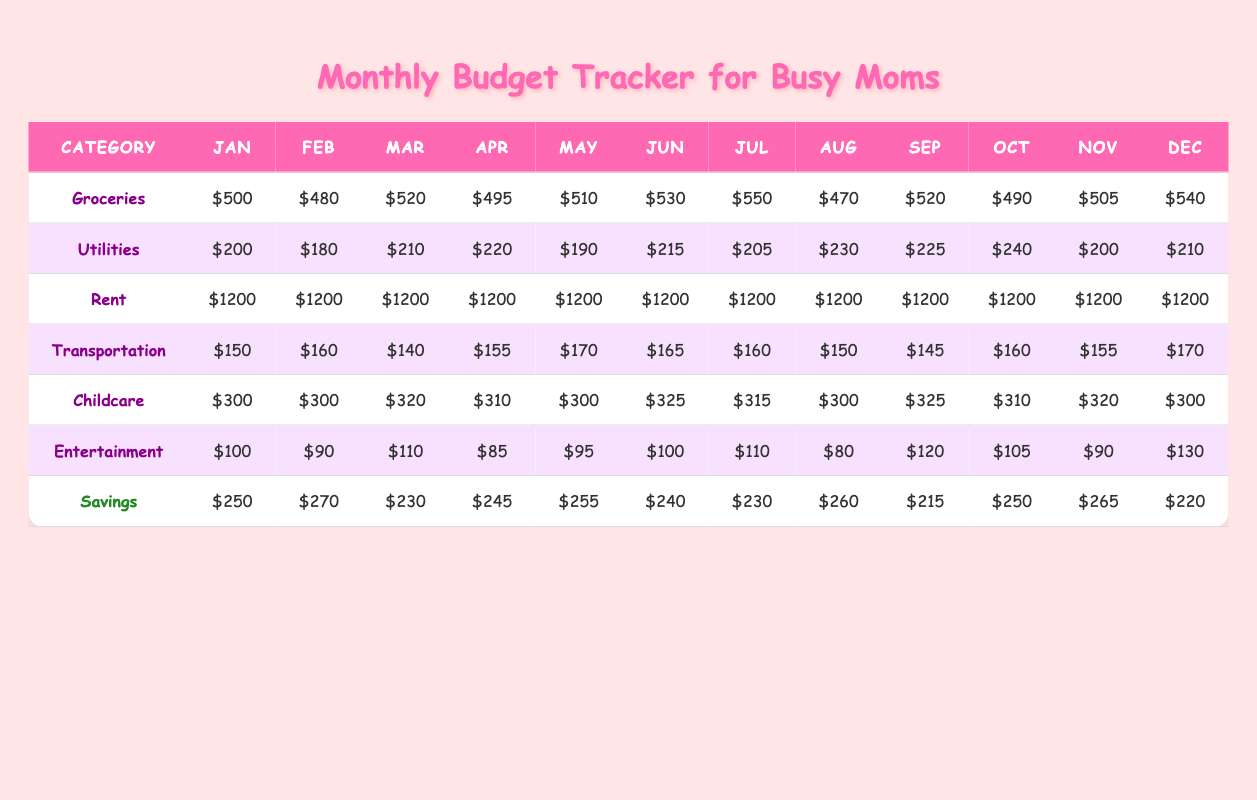What was the highest amount spent on groceries in any month? Looking at the "Groceries" row, the highest monthly value is $550 in July.
Answer: $550 In which month did the household spend the least on utilities? The "Utilities" row shows the lowest amount spent is $180 in February.
Answer: $180 What is the total amount spent on childcare from January to March? Summing the childcare amounts for January ($300), February ($300), and March ($320) gives $300 + $300 + $320 = $920.
Answer: $920 Did the household spend less than $100 on entertainment in any month? Reviewing the "Entertainment" row, they spent less than $100 only in April, where it was $85.
Answer: Yes What was the change in savings from January to December? Savings in January were $250 and in December they were $220. The difference is $220 - $250 = -$30.
Answer: -$30 Which month had the highest total spending overall? Calculating total spending for each month, July ($2,150) has the highest total.
Answer: July What was the average monthly cost of rent for the household over the year? Rent was consistently $1200 for each month, so the average is simply $1200.
Answer: $1200 How much did the household spend on groceries in August compared to June? Groceries were $470 in August and $530 in June. The difference is $530 - $470 = $60.
Answer: $60 Which category saw the biggest increase in spending from February to March? Looking at the month-to-month changes: Groceries increased by $40, Utilities by $30, Transportation decreased by $20, Childcare increased by $20, Entertainment increased by $20. The biggest increase was in Groceries.
Answer: Groceries Was the total savings for the year more than $2,800? Adding up the savings for each month gives $250 + $270 + $230 + $245 + $255 + $240 + $230 + $260 + $215 + $250 + $265 + $220 = $3,025, which is more than $2,800.
Answer: Yes 